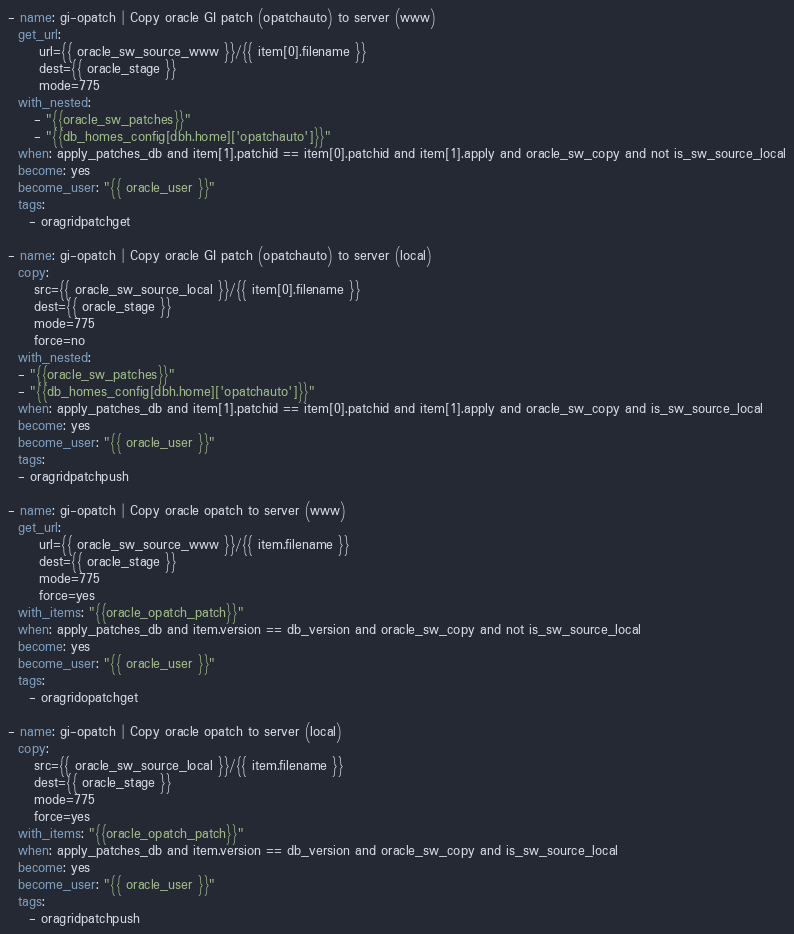<code> <loc_0><loc_0><loc_500><loc_500><_YAML_>- name: gi-opatch | Copy oracle GI patch (opatchauto) to server (www)
  get_url:
      url={{ oracle_sw_source_www }}/{{ item[0].filename }}
      dest={{ oracle_stage }}
      mode=775
  with_nested:
     - "{{oracle_sw_patches}}"
     - "{{db_homes_config[dbh.home]['opatchauto']}}"
  when: apply_patches_db and item[1].patchid == item[0].patchid and item[1].apply and oracle_sw_copy and not is_sw_source_local
  become: yes
  become_user: "{{ oracle_user }}"
  tags:
    - oragridpatchget

- name: gi-opatch | Copy oracle GI patch (opatchauto) to server (local)
  copy:
     src={{ oracle_sw_source_local }}/{{ item[0].filename }}
     dest={{ oracle_stage }}
     mode=775
     force=no
  with_nested:
  - "{{oracle_sw_patches}}"
  - "{{db_homes_config[dbh.home]['opatchauto']}}"
  when: apply_patches_db and item[1].patchid == item[0].patchid and item[1].apply and oracle_sw_copy and is_sw_source_local
  become: yes
  become_user: "{{ oracle_user }}"
  tags:
  - oragridpatchpush

- name: gi-opatch | Copy oracle opatch to server (www)
  get_url:
      url={{ oracle_sw_source_www }}/{{ item.filename }}
      dest={{ oracle_stage }}
      mode=775
      force=yes
  with_items: "{{oracle_opatch_patch}}"
  when: apply_patches_db and item.version == db_version and oracle_sw_copy and not is_sw_source_local
  become: yes
  become_user: "{{ oracle_user }}"
  tags:
    - oragridopatchget

- name: gi-opatch | Copy oracle opatch to server (local)
  copy:
     src={{ oracle_sw_source_local }}/{{ item.filename }}
     dest={{ oracle_stage }}
     mode=775
     force=yes
  with_items: "{{oracle_opatch_patch}}"
  when: apply_patches_db and item.version == db_version and oracle_sw_copy and is_sw_source_local
  become: yes
  become_user: "{{ oracle_user }}"
  tags:
    - oragridpatchpush
</code> 